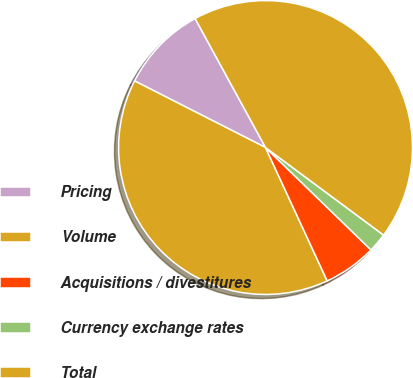<chart> <loc_0><loc_0><loc_500><loc_500><pie_chart><fcel>Pricing<fcel>Volume<fcel>Acquisitions / divestitures<fcel>Currency exchange rates<fcel>Total<nl><fcel>9.56%<fcel>39.38%<fcel>5.84%<fcel>2.11%<fcel>43.11%<nl></chart> 